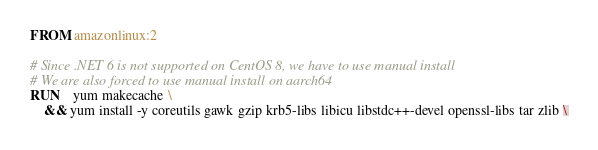Convert code to text. <code><loc_0><loc_0><loc_500><loc_500><_Dockerfile_>FROM amazonlinux:2

# Since .NET 6 is not supported on CentOS 8, we have to use manual install
# We are also forced to use manual install on aarch64
RUN    yum makecache \
    && yum install -y coreutils gawk gzip krb5-libs libicu libstdc++-devel openssl-libs tar zlib \</code> 